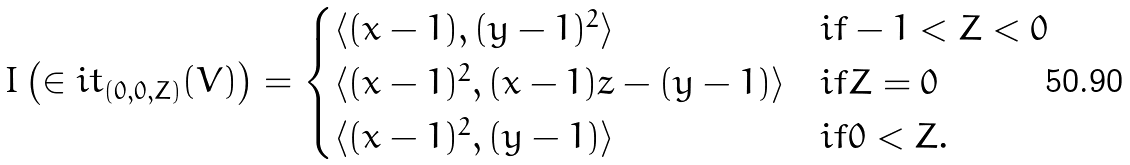Convert formula to latex. <formula><loc_0><loc_0><loc_500><loc_500>I \left ( \in i t _ { ( 0 , 0 , Z ) } ( V ) \right ) = \begin{cases} \langle ( x - 1 ) , ( y - 1 ) ^ { 2 } \rangle & i f - 1 < Z < 0 \\ \langle ( x - 1 ) ^ { 2 } , ( x - 1 ) z - ( y - 1 ) \rangle & i f Z = 0 \\ \langle ( x - 1 ) ^ { 2 } , ( y - 1 ) \rangle & i f 0 < Z . \end{cases}</formula> 